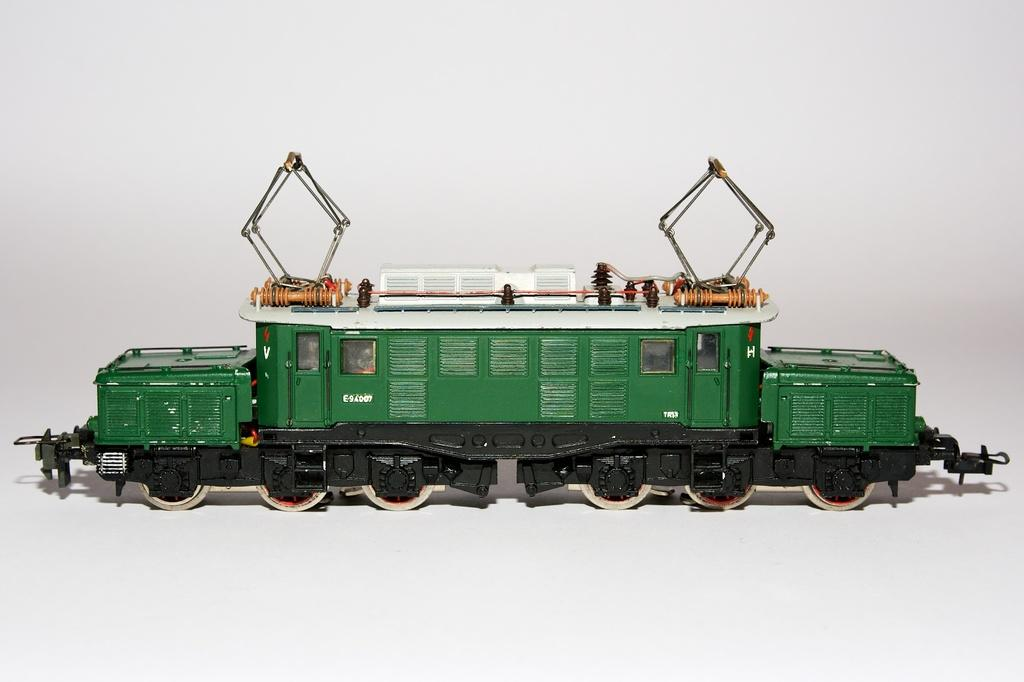What is the main subject of the image? The main subject of the image is a train. What colors can be seen on the train? The train has black, green, and white colors. What color is the background of the image? The background of the image is white. What type of linen is being used to cover the wilderness in the image? There is no linen or wilderness present in the image; it features a train with black, green, and white colors against a white background. 